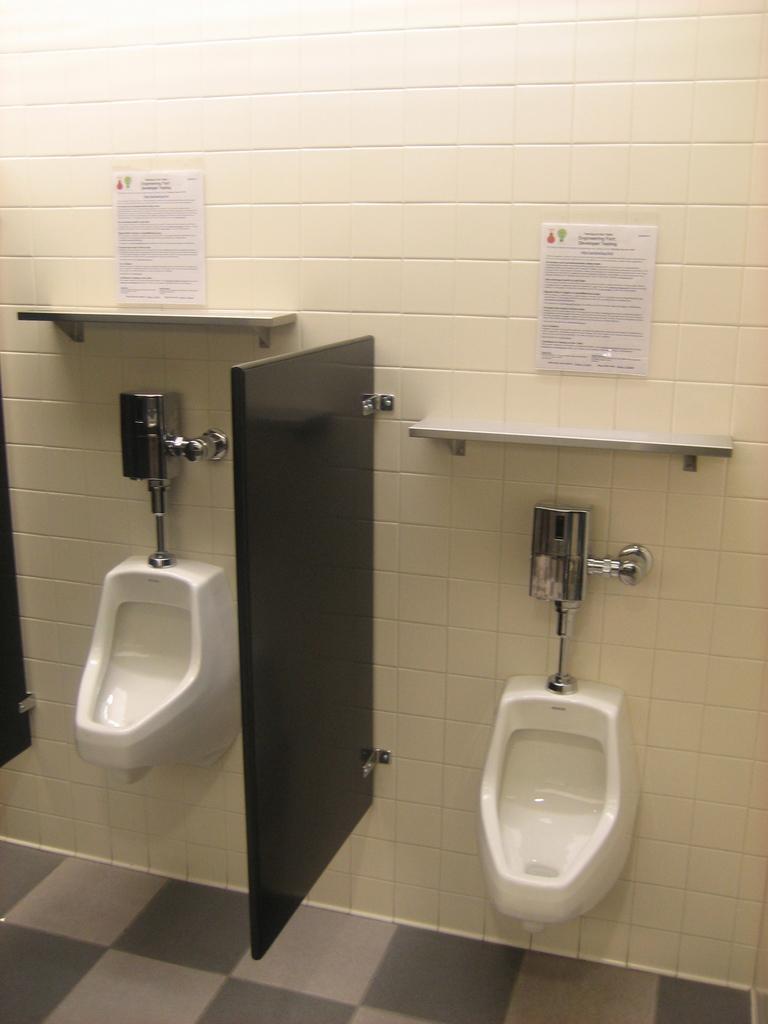Could you give a brief overview of what you see in this image? In the picture we can see inside the washroom with toilet, sinks to the wall with pipes and in the middle of it, we can see the marble wall which is attached to the wall and on the wall we can see two note boards. 